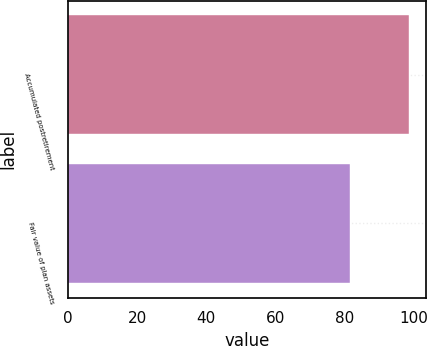Convert chart. <chart><loc_0><loc_0><loc_500><loc_500><bar_chart><fcel>Accumulated postretirement<fcel>Fair value of plan assets<nl><fcel>98.7<fcel>81.7<nl></chart> 